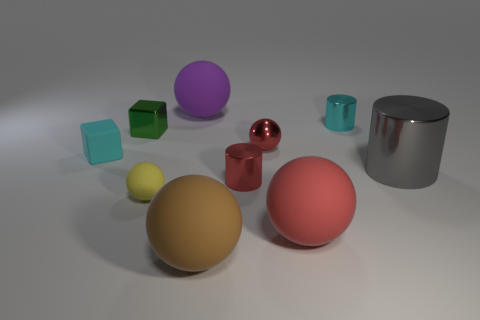Subtract all brown spheres. How many spheres are left? 4 Subtract all tiny red balls. How many balls are left? 4 Subtract all gray blocks. Subtract all yellow cylinders. How many blocks are left? 2 Subtract all blocks. How many objects are left? 8 Add 3 gray shiny cylinders. How many gray shiny cylinders are left? 4 Add 4 red metallic blocks. How many red metallic blocks exist? 4 Subtract 1 green cubes. How many objects are left? 9 Subtract all big gray metallic objects. Subtract all tiny red metallic balls. How many objects are left? 8 